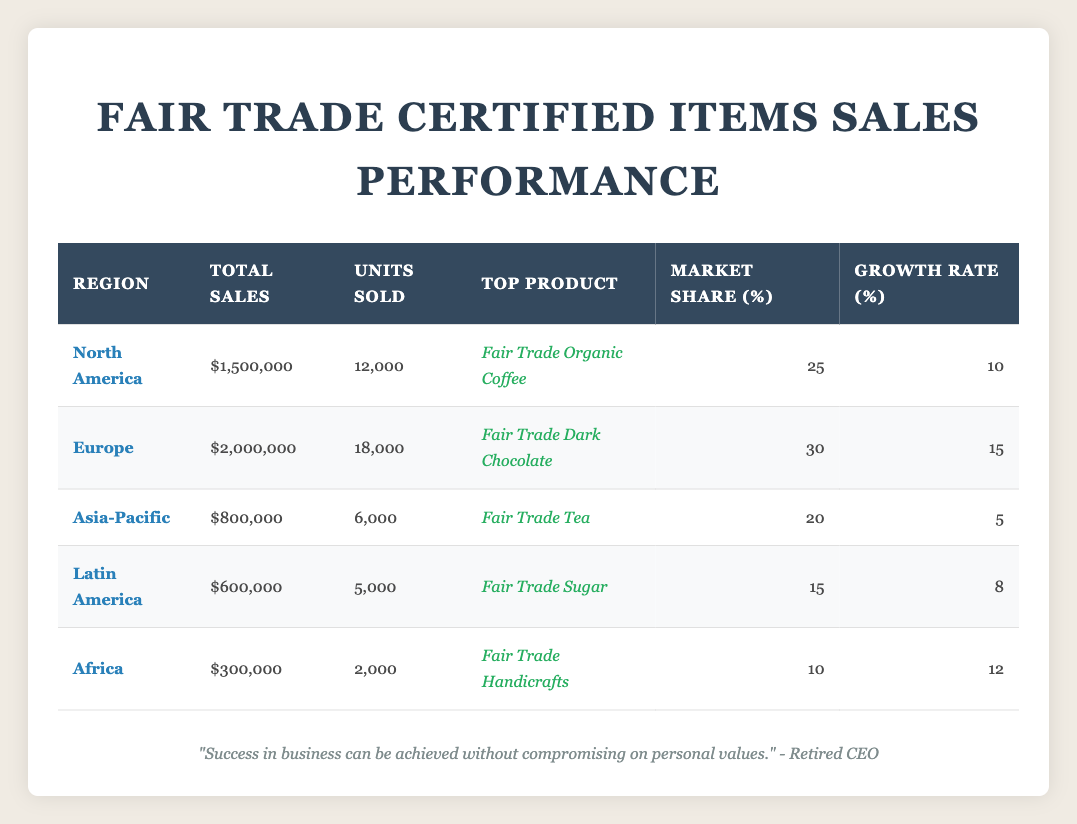What is the total sales figure for Europe? The total sales figure for Europe is listed directly in the table under the "Total Sales" column for that region, which is $2,000,000.
Answer: $2,000,000 Which region has the highest market share? Referring to the "Market Share (%)" column, we can see that Europe has the highest market share at 30%.
Answer: Europe What is the top product sold in North America? The "Top Product" for North America is specified in the table under the respective column, which is Fair Trade Organic Coffee.
Answer: Fair Trade Organic Coffee What is the average growth rate of all regions? To find the average growth rate, add all growth rates together: (10 + 15 + 5 + 8 + 12) = 50. Then divide by the number of regions (5): 50/5 = 10. Therefore, the average growth rate is 10%.
Answer: 10 Is it true that Latin America has the highest total sales? By comparing the "Total Sales" figures, we see that Latin America's total sales of $600,000 is less than both Europe and North America, which means the statement is false.
Answer: No What region experienced the lowest units sold? The "Units Sold" column shows Africa with 2,000 units sold, which is the lowest among all regions.
Answer: Africa If we consider the regions with a growth rate above 10%, how many regions are there? We assess the growth rates: North America (10), Europe (15), Asia-Pacific (5), Latin America (8), and Africa (12). The regions with growth rates above 10% are Europe (15) and Africa (12), totaling 2 regions.
Answer: 2 Which region's top product is Fair Trade Tea? Looking at the "Top Product" column, we find that Fair Trade Tea is listed for the Asia-Pacific region.
Answer: Asia-Pacific What is the difference in total sales between North America and Africa? The total sales for North America is $1,500,000, and for Africa, it is $300,000. The difference is calculated as $1,500,000 - $300,000 = $1,200,000.
Answer: $1,200,000 